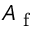Convert formula to latex. <formula><loc_0><loc_0><loc_500><loc_500>A _ { f }</formula> 